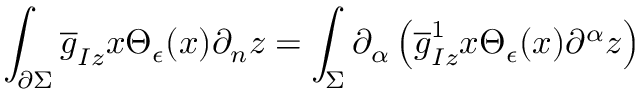<formula> <loc_0><loc_0><loc_500><loc_500>\int _ { \partial \Sigma } { \overline { g } } _ { I z } x \Theta _ { \epsilon } ( x ) \partial _ { n } z = \int _ { \Sigma } \partial _ { \alpha } \left ( { \overline { g } } _ { I z } ^ { 1 } x \Theta _ { \epsilon } ( x ) \partial ^ { \alpha } z \right )</formula> 